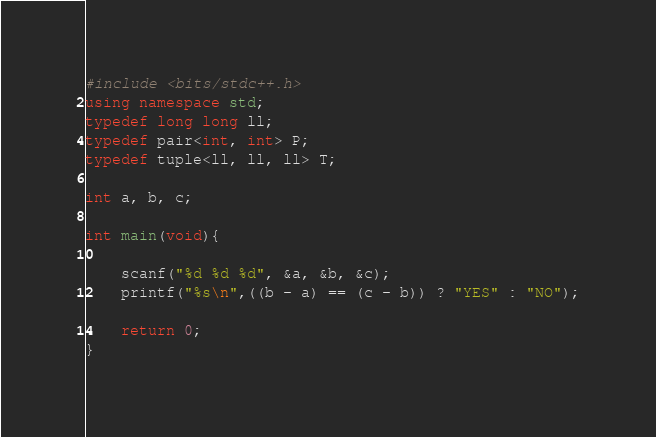Convert code to text. <code><loc_0><loc_0><loc_500><loc_500><_C++_>#include <bits/stdc++.h>
using namespace std;
typedef long long ll;
typedef pair<int, int> P;
typedef tuple<ll, ll, ll> T;

int a, b, c;

int main(void){
    
    scanf("%d %d %d", &a, &b, &c);
    printf("%s\n",((b - a) == (c - b)) ? "YES" : "NO");
    
    return 0;
}</code> 